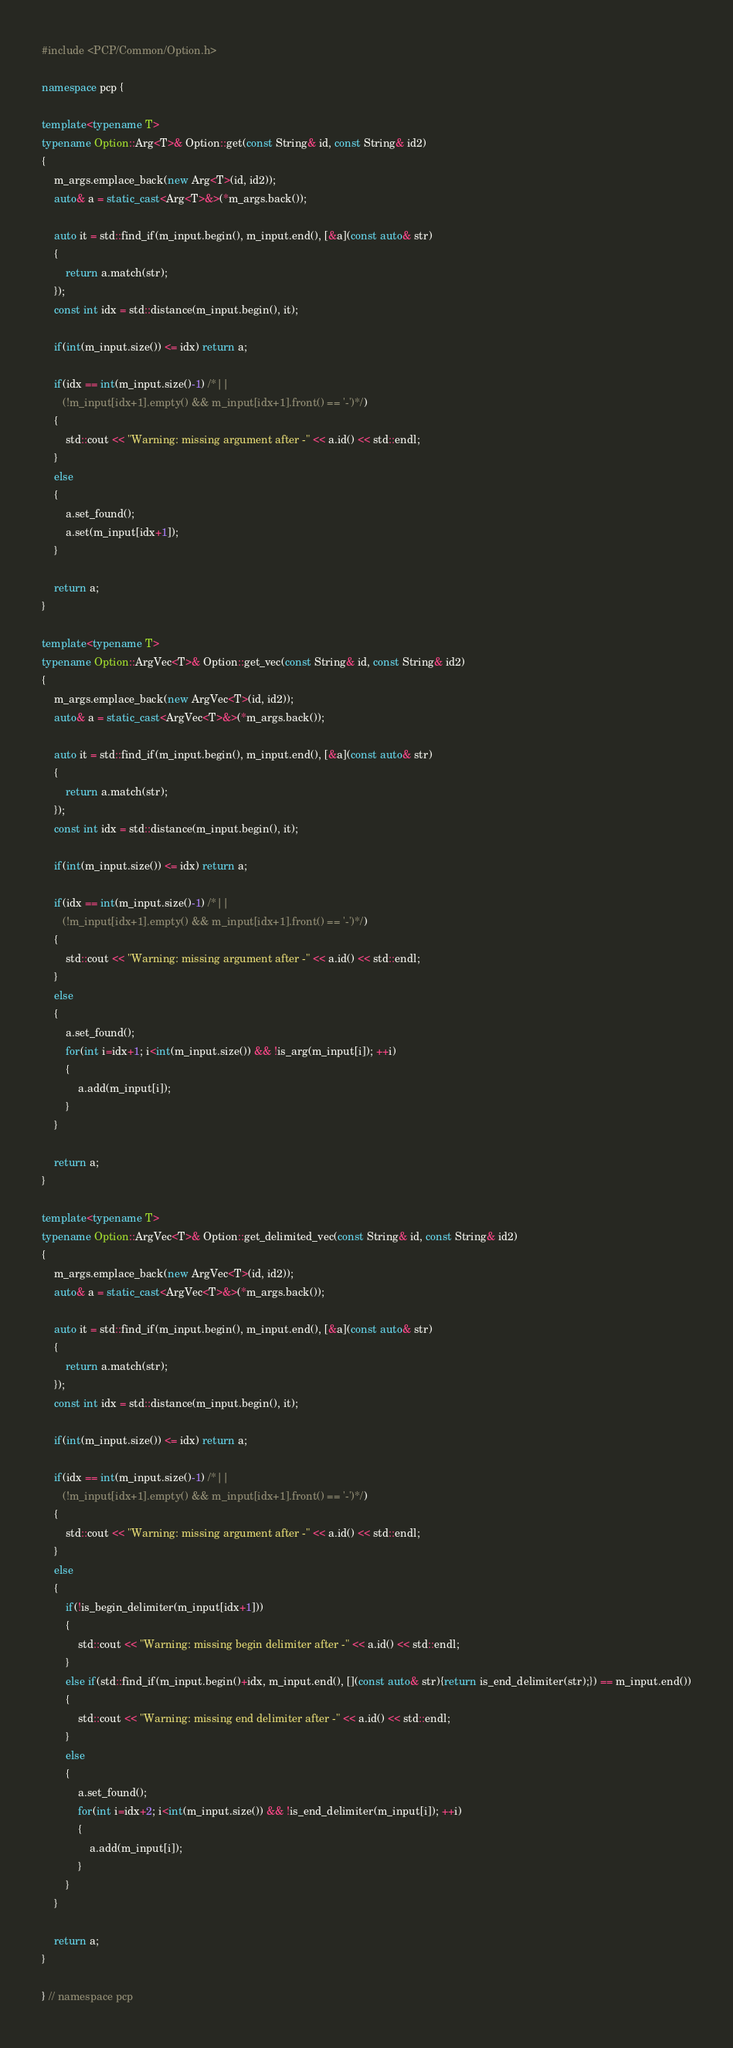Convert code to text. <code><loc_0><loc_0><loc_500><loc_500><_C++_>#include <PCP/Common/Option.h>

namespace pcp {

template<typename T>
typename Option::Arg<T>& Option::get(const String& id, const String& id2)
{
    m_args.emplace_back(new Arg<T>(id, id2));
    auto& a = static_cast<Arg<T>&>(*m_args.back());

    auto it = std::find_if(m_input.begin(), m_input.end(), [&a](const auto& str)
    {
        return a.match(str);
    });
    const int idx = std::distance(m_input.begin(), it);

    if(int(m_input.size()) <= idx) return a;

    if(idx == int(m_input.size()-1) /*||
       (!m_input[idx+1].empty() && m_input[idx+1].front() == '-')*/)
    {
        std::cout << "Warning: missing argument after -" << a.id() << std::endl;
    }
    else
    {
        a.set_found();
        a.set(m_input[idx+1]);
    }

    return a;
}

template<typename T>
typename Option::ArgVec<T>& Option::get_vec(const String& id, const String& id2)
{
    m_args.emplace_back(new ArgVec<T>(id, id2));
    auto& a = static_cast<ArgVec<T>&>(*m_args.back());

    auto it = std::find_if(m_input.begin(), m_input.end(), [&a](const auto& str)
    {
        return a.match(str);
    });
    const int idx = std::distance(m_input.begin(), it);

    if(int(m_input.size()) <= idx) return a;

    if(idx == int(m_input.size()-1) /*||
       (!m_input[idx+1].empty() && m_input[idx+1].front() == '-')*/)
    {
        std::cout << "Warning: missing argument after -" << a.id() << std::endl;
    }
    else
    {
        a.set_found();
        for(int i=idx+1; i<int(m_input.size()) && !is_arg(m_input[i]); ++i)
        {
            a.add(m_input[i]);
        }
    }

    return a;
}

template<typename T>
typename Option::ArgVec<T>& Option::get_delimited_vec(const String& id, const String& id2)
{
    m_args.emplace_back(new ArgVec<T>(id, id2));
    auto& a = static_cast<ArgVec<T>&>(*m_args.back());

    auto it = std::find_if(m_input.begin(), m_input.end(), [&a](const auto& str)
    {
        return a.match(str);
    });
    const int idx = std::distance(m_input.begin(), it);

    if(int(m_input.size()) <= idx) return a;

    if(idx == int(m_input.size()-1) /*||
       (!m_input[idx+1].empty() && m_input[idx+1].front() == '-')*/)
    {
        std::cout << "Warning: missing argument after -" << a.id() << std::endl;
    }
    else
    {
        if(!is_begin_delimiter(m_input[idx+1]))
        {
            std::cout << "Warning: missing begin delimiter after -" << a.id() << std::endl;
        }
        else if(std::find_if(m_input.begin()+idx, m_input.end(), [](const auto& str){return is_end_delimiter(str);}) == m_input.end())
        {
            std::cout << "Warning: missing end delimiter after -" << a.id() << std::endl;
        }
        else
        {
            a.set_found();
            for(int i=idx+2; i<int(m_input.size()) && !is_end_delimiter(m_input[i]); ++i)
            {
                a.add(m_input[i]);
            }
        }
    }

    return a;
}

} // namespace pcp
</code> 